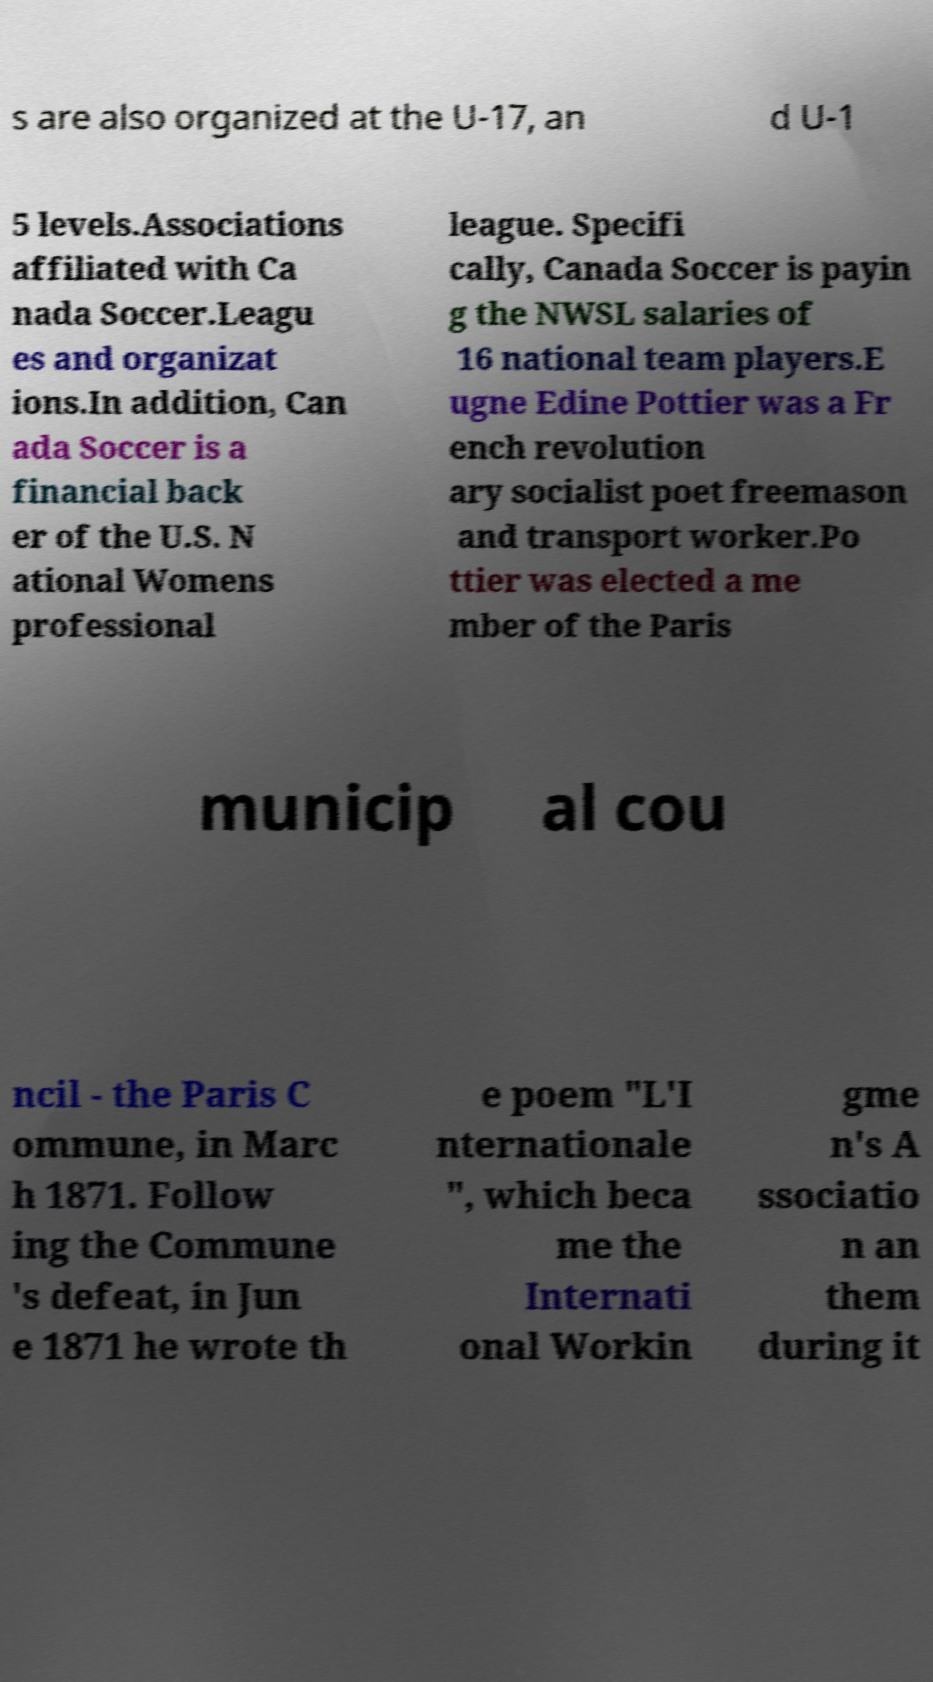Please identify and transcribe the text found in this image. s are also organized at the U-17, an d U-1 5 levels.Associations affiliated with Ca nada Soccer.Leagu es and organizat ions.In addition, Can ada Soccer is a financial back er of the U.S. N ational Womens professional league. Specifi cally, Canada Soccer is payin g the NWSL salaries of 16 national team players.E ugne Edine Pottier was a Fr ench revolution ary socialist poet freemason and transport worker.Po ttier was elected a me mber of the Paris municip al cou ncil - the Paris C ommune, in Marc h 1871. Follow ing the Commune 's defeat, in Jun e 1871 he wrote th e poem "L'I nternationale ", which beca me the Internati onal Workin gme n's A ssociatio n an them during it 